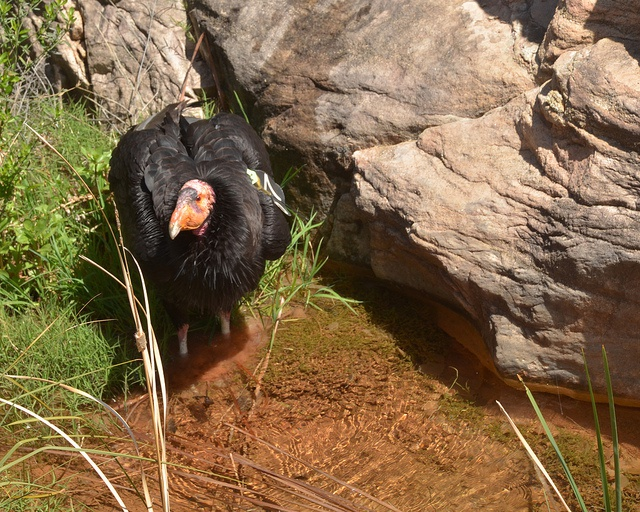Describe the objects in this image and their specific colors. I can see a bird in olive, black, and gray tones in this image. 